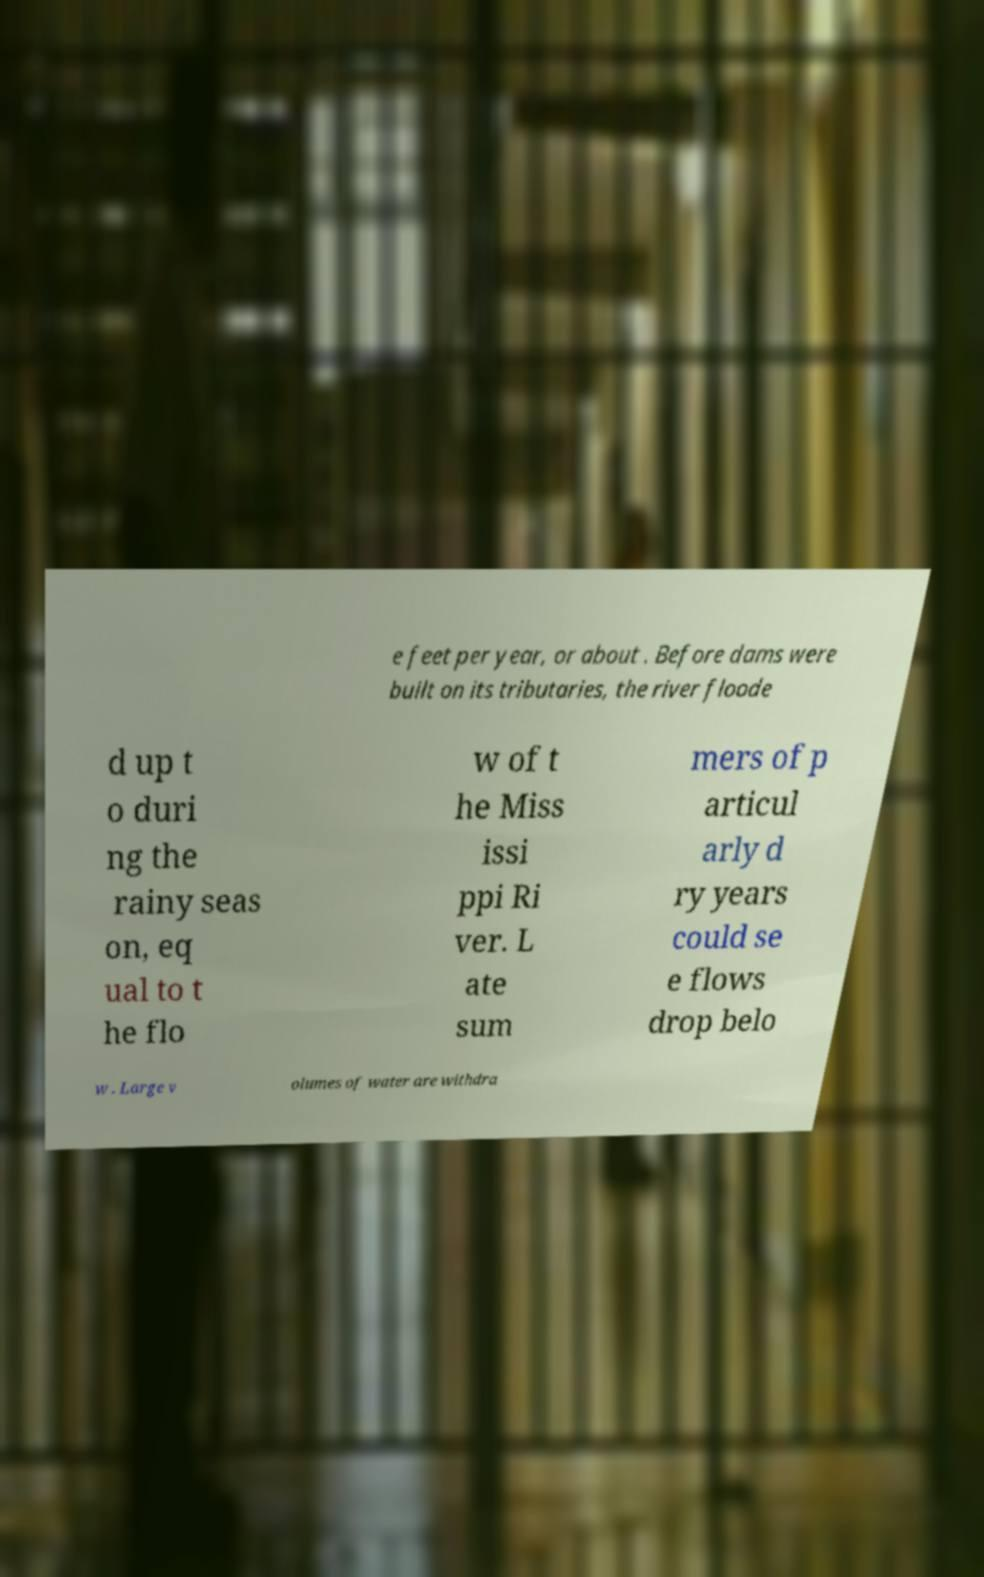What messages or text are displayed in this image? I need them in a readable, typed format. e feet per year, or about . Before dams were built on its tributaries, the river floode d up t o duri ng the rainy seas on, eq ual to t he flo w of t he Miss issi ppi Ri ver. L ate sum mers of p articul arly d ry years could se e flows drop belo w . Large v olumes of water are withdra 